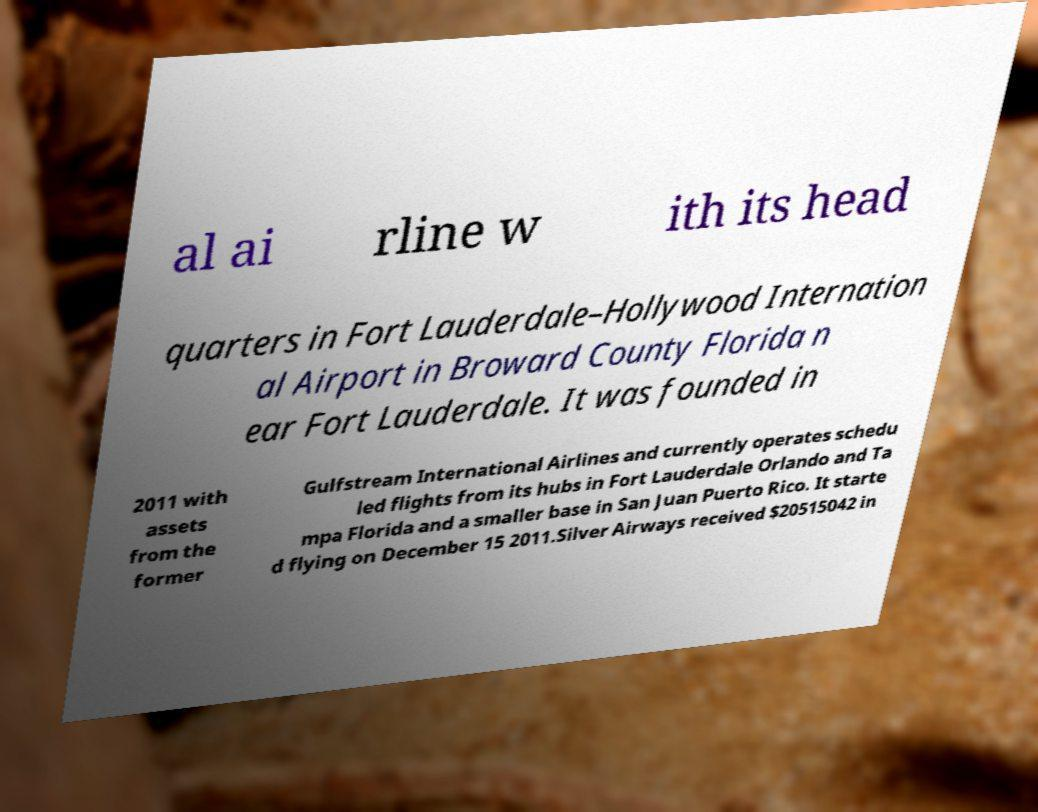Please read and relay the text visible in this image. What does it say? al ai rline w ith its head quarters in Fort Lauderdale–Hollywood Internation al Airport in Broward County Florida n ear Fort Lauderdale. It was founded in 2011 with assets from the former Gulfstream International Airlines and currently operates schedu led flights from its hubs in Fort Lauderdale Orlando and Ta mpa Florida and a smaller base in San Juan Puerto Rico. It starte d flying on December 15 2011.Silver Airways received $20515042 in 